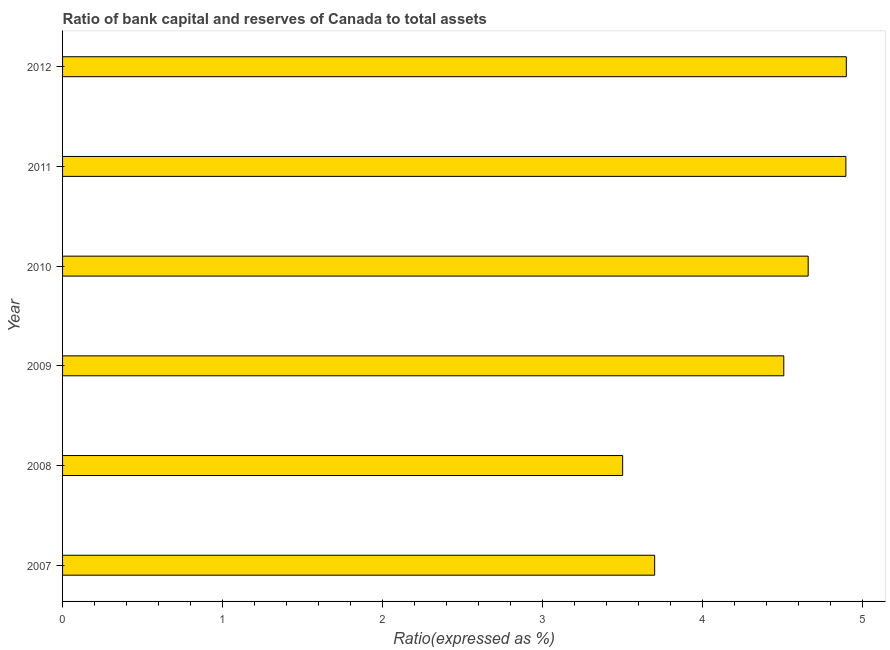Does the graph contain any zero values?
Offer a terse response. No. What is the title of the graph?
Provide a succinct answer. Ratio of bank capital and reserves of Canada to total assets. What is the label or title of the X-axis?
Your response must be concise. Ratio(expressed as %). What is the bank capital to assets ratio in 2009?
Provide a short and direct response. 4.51. Across all years, what is the maximum bank capital to assets ratio?
Offer a terse response. 4.9. In which year was the bank capital to assets ratio maximum?
Your answer should be compact. 2012. What is the sum of the bank capital to assets ratio?
Keep it short and to the point. 26.16. What is the difference between the bank capital to assets ratio in 2007 and 2009?
Provide a succinct answer. -0.81. What is the average bank capital to assets ratio per year?
Offer a terse response. 4.36. What is the median bank capital to assets ratio?
Provide a succinct answer. 4.58. In how many years, is the bank capital to assets ratio greater than 0.4 %?
Ensure brevity in your answer.  6. Do a majority of the years between 2011 and 2010 (inclusive) have bank capital to assets ratio greater than 3.2 %?
Make the answer very short. No. What is the ratio of the bank capital to assets ratio in 2008 to that in 2010?
Offer a terse response. 0.75. Is the bank capital to assets ratio in 2008 less than that in 2009?
Ensure brevity in your answer.  Yes. What is the difference between the highest and the second highest bank capital to assets ratio?
Provide a short and direct response. 0. What is the difference between the highest and the lowest bank capital to assets ratio?
Provide a succinct answer. 1.4. How many bars are there?
Provide a short and direct response. 6. Are all the bars in the graph horizontal?
Offer a very short reply. Yes. How many years are there in the graph?
Ensure brevity in your answer.  6. What is the difference between two consecutive major ticks on the X-axis?
Provide a short and direct response. 1. Are the values on the major ticks of X-axis written in scientific E-notation?
Provide a short and direct response. No. What is the Ratio(expressed as %) of 2009?
Offer a very short reply. 4.51. What is the Ratio(expressed as %) in 2010?
Ensure brevity in your answer.  4.66. What is the Ratio(expressed as %) in 2011?
Your answer should be compact. 4.89. What is the Ratio(expressed as %) in 2012?
Offer a very short reply. 4.9. What is the difference between the Ratio(expressed as %) in 2007 and 2008?
Give a very brief answer. 0.2. What is the difference between the Ratio(expressed as %) in 2007 and 2009?
Ensure brevity in your answer.  -0.81. What is the difference between the Ratio(expressed as %) in 2007 and 2010?
Make the answer very short. -0.96. What is the difference between the Ratio(expressed as %) in 2007 and 2011?
Your answer should be compact. -1.19. What is the difference between the Ratio(expressed as %) in 2007 and 2012?
Provide a short and direct response. -1.2. What is the difference between the Ratio(expressed as %) in 2008 and 2009?
Keep it short and to the point. -1.01. What is the difference between the Ratio(expressed as %) in 2008 and 2010?
Your answer should be very brief. -1.16. What is the difference between the Ratio(expressed as %) in 2008 and 2011?
Make the answer very short. -1.39. What is the difference between the Ratio(expressed as %) in 2008 and 2012?
Offer a terse response. -1.4. What is the difference between the Ratio(expressed as %) in 2009 and 2010?
Your answer should be compact. -0.15. What is the difference between the Ratio(expressed as %) in 2009 and 2011?
Provide a short and direct response. -0.39. What is the difference between the Ratio(expressed as %) in 2009 and 2012?
Ensure brevity in your answer.  -0.39. What is the difference between the Ratio(expressed as %) in 2010 and 2011?
Ensure brevity in your answer.  -0.24. What is the difference between the Ratio(expressed as %) in 2010 and 2012?
Your answer should be very brief. -0.24. What is the difference between the Ratio(expressed as %) in 2011 and 2012?
Keep it short and to the point. -0. What is the ratio of the Ratio(expressed as %) in 2007 to that in 2008?
Offer a terse response. 1.06. What is the ratio of the Ratio(expressed as %) in 2007 to that in 2009?
Offer a terse response. 0.82. What is the ratio of the Ratio(expressed as %) in 2007 to that in 2010?
Your response must be concise. 0.79. What is the ratio of the Ratio(expressed as %) in 2007 to that in 2011?
Provide a short and direct response. 0.76. What is the ratio of the Ratio(expressed as %) in 2007 to that in 2012?
Provide a succinct answer. 0.76. What is the ratio of the Ratio(expressed as %) in 2008 to that in 2009?
Offer a very short reply. 0.78. What is the ratio of the Ratio(expressed as %) in 2008 to that in 2010?
Your response must be concise. 0.75. What is the ratio of the Ratio(expressed as %) in 2008 to that in 2011?
Your answer should be very brief. 0.71. What is the ratio of the Ratio(expressed as %) in 2008 to that in 2012?
Offer a very short reply. 0.71. What is the ratio of the Ratio(expressed as %) in 2009 to that in 2011?
Ensure brevity in your answer.  0.92. What is the ratio of the Ratio(expressed as %) in 2010 to that in 2012?
Offer a very short reply. 0.95. 